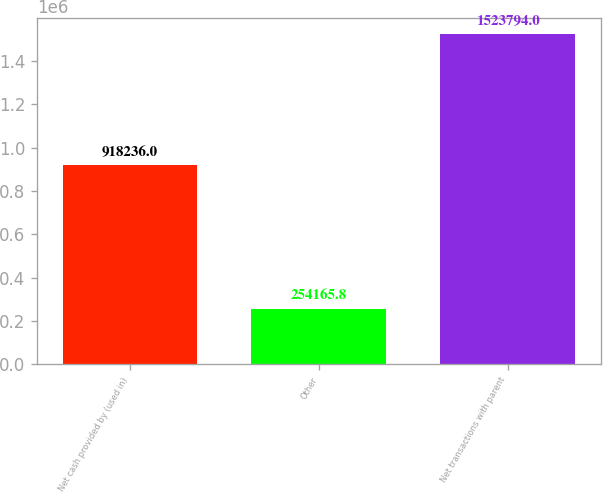Convert chart. <chart><loc_0><loc_0><loc_500><loc_500><bar_chart><fcel>Net cash provided by (used in)<fcel>Other<fcel>Net transactions with parent<nl><fcel>918236<fcel>254166<fcel>1.52379e+06<nl></chart> 